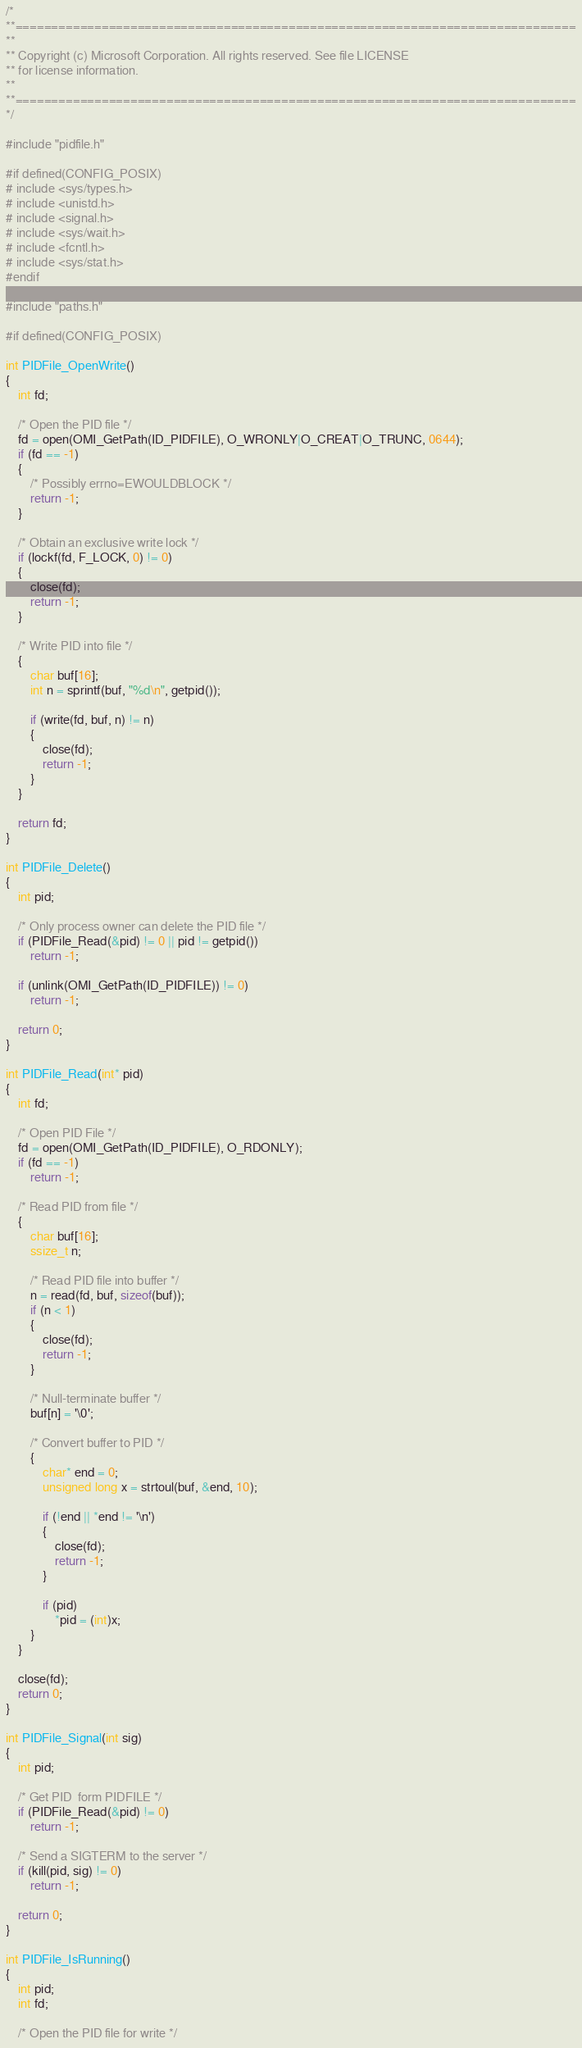Convert code to text. <code><loc_0><loc_0><loc_500><loc_500><_C_>/*
**==============================================================================
**
** Copyright (c) Microsoft Corporation. All rights reserved. See file LICENSE
** for license information.
**
**==============================================================================
*/

#include "pidfile.h"

#if defined(CONFIG_POSIX)
# include <sys/types.h>
# include <unistd.h>
# include <signal.h>
# include <sys/wait.h>
# include <fcntl.h>
# include <sys/stat.h>
#endif

#include "paths.h"

#if defined(CONFIG_POSIX)

int PIDFile_OpenWrite()
{
    int fd;

    /* Open the PID file */
    fd = open(OMI_GetPath(ID_PIDFILE), O_WRONLY|O_CREAT|O_TRUNC, 0644);
    if (fd == -1)
    {
        /* Possibly errno=EWOULDBLOCK */
        return -1;
    }

    /* Obtain an exclusive write lock */
    if (lockf(fd, F_LOCK, 0) != 0)
    {
        close(fd);
        return -1;
    }

    /* Write PID into file */
    {
        char buf[16];
        int n = sprintf(buf, "%d\n", getpid());

        if (write(fd, buf, n) != n)
        {
            close(fd);
            return -1;
        }
    }

    return fd;
}

int PIDFile_Delete()
{
    int pid;

    /* Only process owner can delete the PID file */
    if (PIDFile_Read(&pid) != 0 || pid != getpid())
        return -1;

    if (unlink(OMI_GetPath(ID_PIDFILE)) != 0)
        return -1;

    return 0;
}

int PIDFile_Read(int* pid)
{
    int fd;
    
    /* Open PID File */
    fd = open(OMI_GetPath(ID_PIDFILE), O_RDONLY);
    if (fd == -1)
        return -1;

    /* Read PID from file */
    {
        char buf[16];
        ssize_t n;
        
        /* Read PID file into buffer */
        n = read(fd, buf, sizeof(buf));
        if (n < 1)
        {
            close(fd);
            return -1;
        }

        /* Null-terminate buffer */
        buf[n] = '\0';

        /* Convert buffer to PID */
        {
            char* end = 0;
            unsigned long x = strtoul(buf, &end, 10);

            if (!end || *end != '\n')
            {
                close(fd);
                return -1;
            }

            if (pid)
                *pid = (int)x;
        }
    }

    close(fd);
    return 0;
}

int PIDFile_Signal(int sig)
{
    int pid;

    /* Get PID  form PIDFILE */
    if (PIDFile_Read(&pid) != 0)
        return -1;

    /* Send a SIGTERM to the server */
    if (kill(pid, sig) != 0)
        return -1;

    return 0;
}

int PIDFile_IsRunning()
{
    int pid;
    int fd;

    /* Open the PID file for write */</code> 